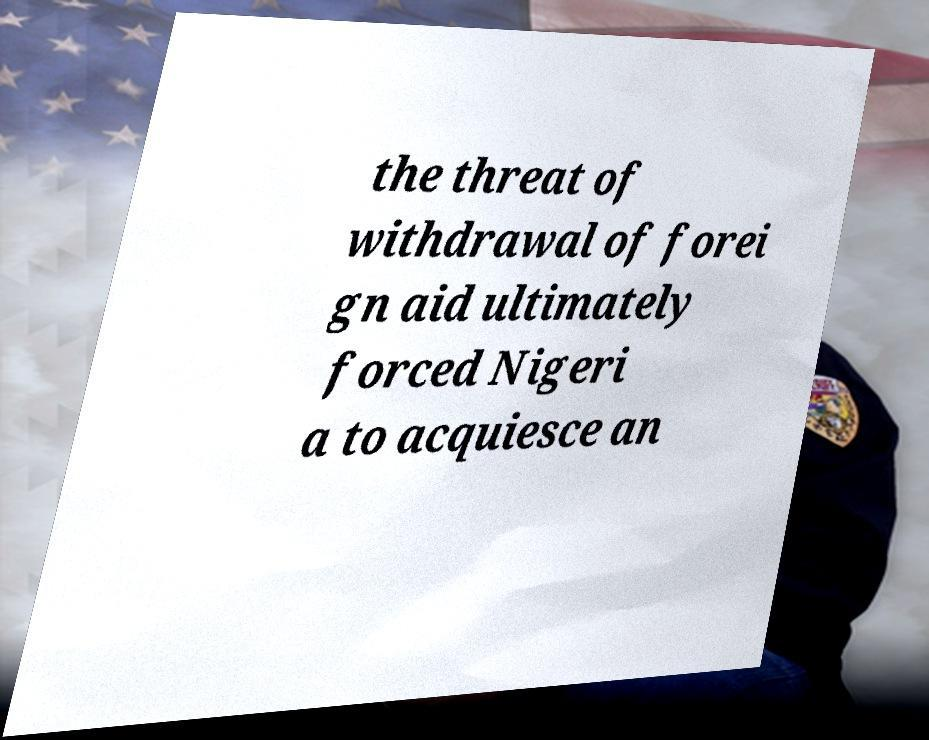What messages or text are displayed in this image? I need them in a readable, typed format. the threat of withdrawal of forei gn aid ultimately forced Nigeri a to acquiesce an 